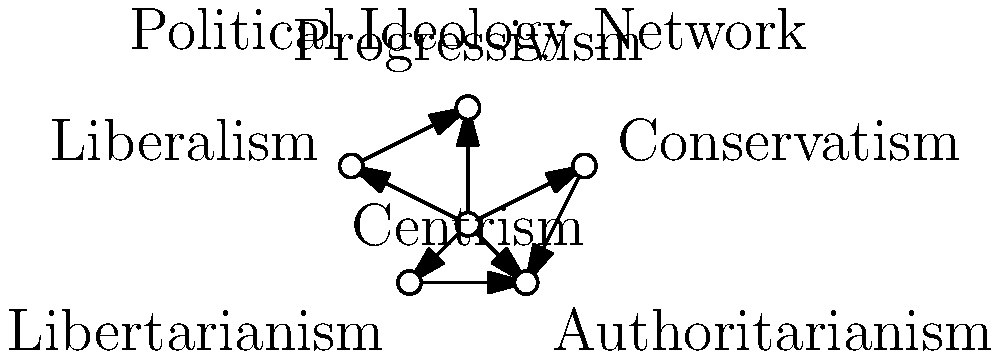In the given network diagram of political ideologies, which ideology serves as the central node connecting all others, and how might this positioning affect a political strategist's approach to maintaining relationship dynamics with a partner committed to impartiality? 1. Analyze the network diagram:
   - Observe that Centrism is positioned at the center of the network.
   - All other ideologies (Conservatism, Liberalism, Progressivism, Libertarianism, and Authoritarianism) are connected to Centrism.

2. Understand the role of Centrism:
   - Centrism acts as a bridge between different political ideologies.
   - It represents a moderate position that can potentially find common ground with various political perspectives.

3. Consider the impact on a political strategist's approach:
   - A centrist position allows for flexibility in navigating different political viewpoints.
   - It provides a neutral ground for discussing various political ideas without strongly aligning with any extreme position.

4. Relate to maintaining relationship dynamics:
   - A centrist approach can help balance personal political beliefs with respect for a partner's impartiality.
   - It allows for engaging in political discussions while minimizing potential conflicts arising from strongly opposing views.

5. Strategic implications:
   - The political strategist can use centrism as a tool to find common ground in discussions.
   - This approach can help maintain professional integrity while respecting personal relationships.

6. Conclusion:
   Centrism's central position in the network highlights its potential as a strategic approach for balancing personal political engagement with respect for impartiality in relationships.
Answer: Centrism; facilitates balanced political discussions while respecting impartiality. 